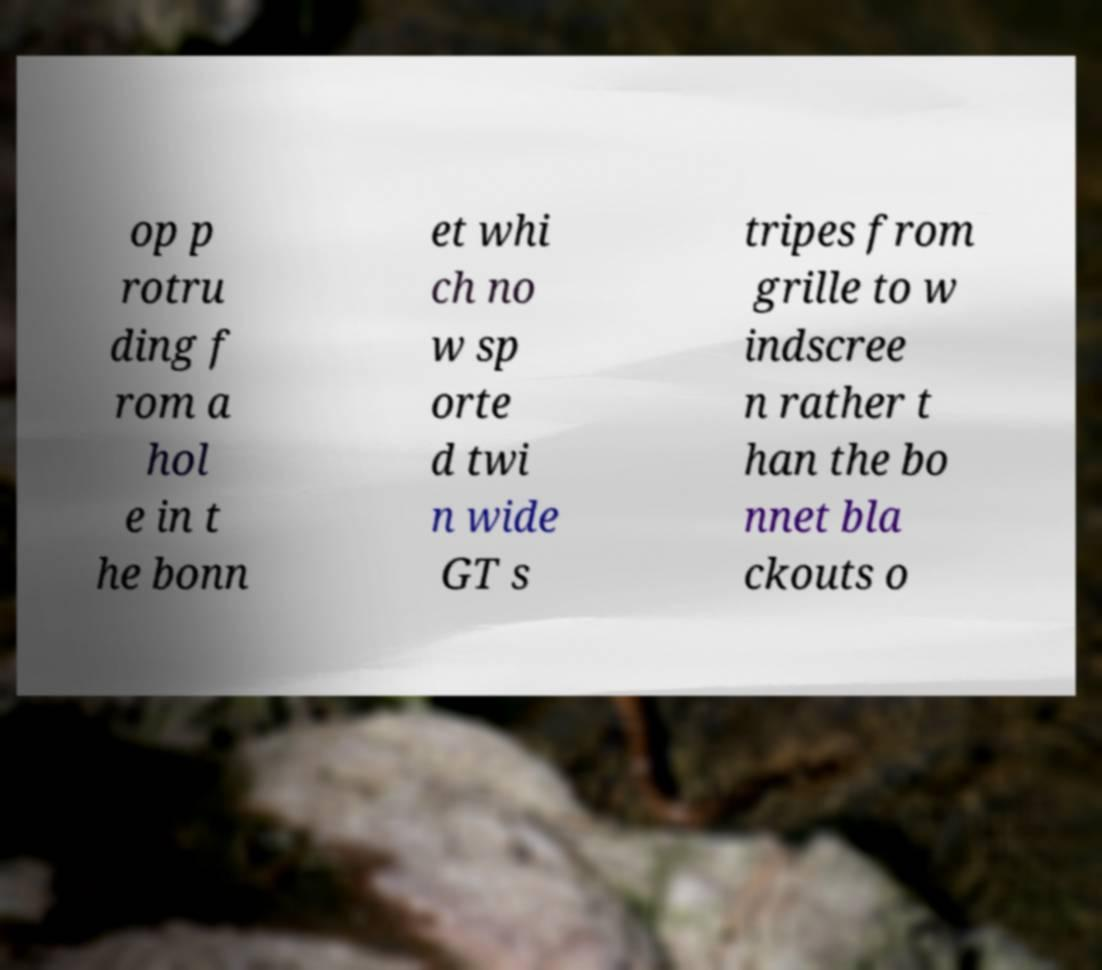Can you read and provide the text displayed in the image?This photo seems to have some interesting text. Can you extract and type it out for me? op p rotru ding f rom a hol e in t he bonn et whi ch no w sp orte d twi n wide GT s tripes from grille to w indscree n rather t han the bo nnet bla ckouts o 